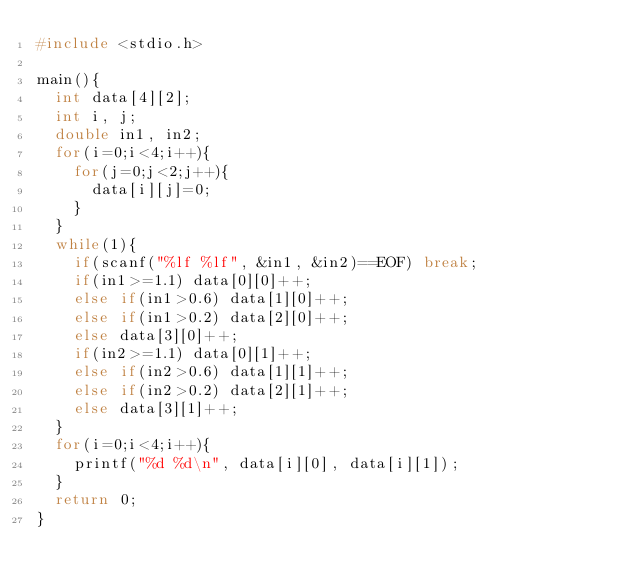<code> <loc_0><loc_0><loc_500><loc_500><_C_>#include <stdio.h>

main(){
  int data[4][2];
  int i, j;
  double in1, in2;
  for(i=0;i<4;i++){
    for(j=0;j<2;j++){
      data[i][j]=0;
    }
  }
  while(1){
    if(scanf("%lf %lf", &in1, &in2)==EOF) break;
    if(in1>=1.1) data[0][0]++;
    else if(in1>0.6) data[1][0]++;
    else if(in1>0.2) data[2][0]++;
    else data[3][0]++;
    if(in2>=1.1) data[0][1]++;
    else if(in2>0.6) data[1][1]++;
    else if(in2>0.2) data[2][1]++;
    else data[3][1]++;
  }
  for(i=0;i<4;i++){
    printf("%d %d\n", data[i][0], data[i][1]);
  }
  return 0;
}</code> 